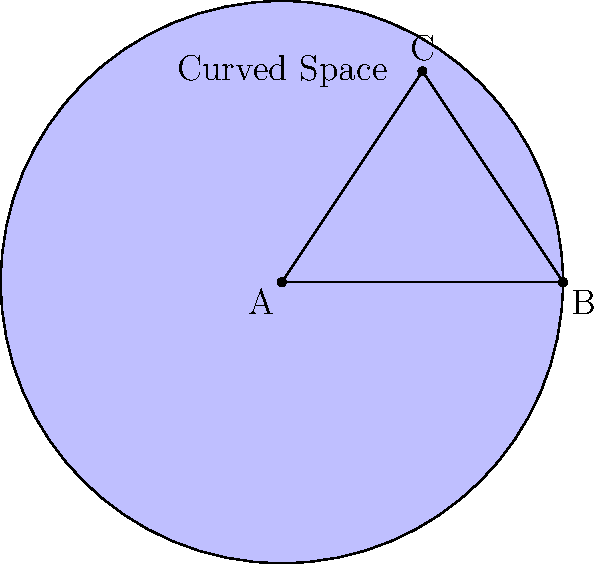In figure skating, understanding non-Euclidean geometry can provide insights into optimizing performance on curved ice surfaces. Consider a triangle ABC on a spherical surface representing a section of the skating rink. If the angles of the triangle are 70°, 65°, and 60°, what is the area of this triangle in square units, assuming the radius of the sphere is 1 unit? How might this concept influence a skater's path choice for maximizing performance scores? To solve this problem and understand its implications for figure skating, let's follow these steps:

1) In spherical geometry, the area of a triangle is given by the formula:

   $A = R^2(α + β + γ - π)$

   Where $R$ is the radius of the sphere, and α, β, and γ are the angles of the triangle in radians.

2) We're given that $R = 1$ unit, so we can simplify our formula to:

   $A = α + β + γ - π$

3) Convert the given angles from degrees to radians:
   
   70° = $\frac{70π}{180}$ radians
   65° = $\frac{65π}{180}$ radians
   60° = $\frac{60π}{180}$ radians

4) Sum the angles:

   $\frac{70π}{180} + \frac{65π}{180} + \frac{60π}{180} = \frac{195π}{180}$

5) Substitute into our area formula:

   $A = \frac{195π}{180} - π = \frac{15π}{180} ≈ 0.2618$ square units

6) Implications for figure skating:

   a) Path optimization: Understanding that the shortest path between two points on a curved surface is not a straight line, but a geodesic, can help skaters optimize their routes for speed and efficiency.
   
   b) Edge control: The curvature of the ice affects how edges interact with the surface. Skaters can use this knowledge to maintain better control and execute more precise movements.
   
   c) Spin dynamics: The non-Euclidean nature of the ice surface can influence the behavior of spins, potentially allowing skaters to achieve higher rotational speeds or maintain spins for longer durations.
   
   d) Jump landings: Understanding the geometry of curved spaces can help skaters calculate optimal landing positions and angles for jumps, potentially increasing stability and reducing the risk of falls.
   
   e) Choreography: Incorporating movements that take advantage of the rink's curvature can lead to more fluid and aesthetically pleasing routines, potentially increasing performance scores.

By applying these concepts, skaters can potentially improve their technical execution, increase their speed and efficiency, and enhance the overall aesthetic appeal of their performances, all of which contribute to higher scores in competitive figure skating.
Answer: 0.2618 square units; influences path optimization, edge control, spin dynamics, jump landings, and choreography for higher scores. 